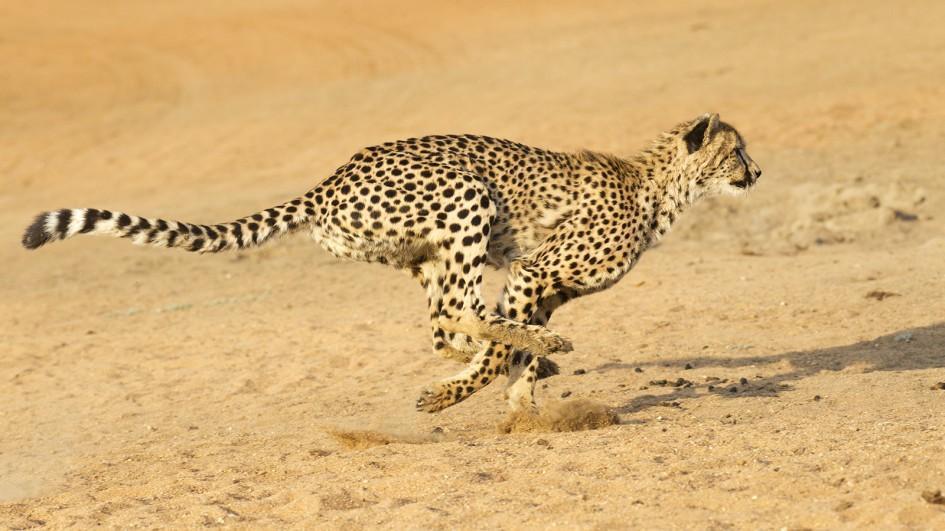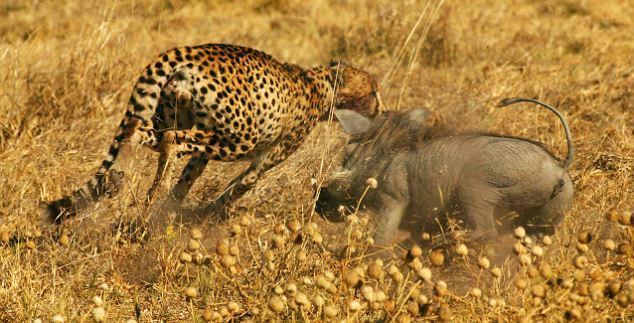The first image is the image on the left, the second image is the image on the right. Examine the images to the left and right. Is the description "Two spotted leopards are standing next to each other." accurate? Answer yes or no. No. The first image is the image on the left, the second image is the image on the right. Given the left and right images, does the statement "There is a least one cheetah in each image peering out through the tall grass." hold true? Answer yes or no. No. 